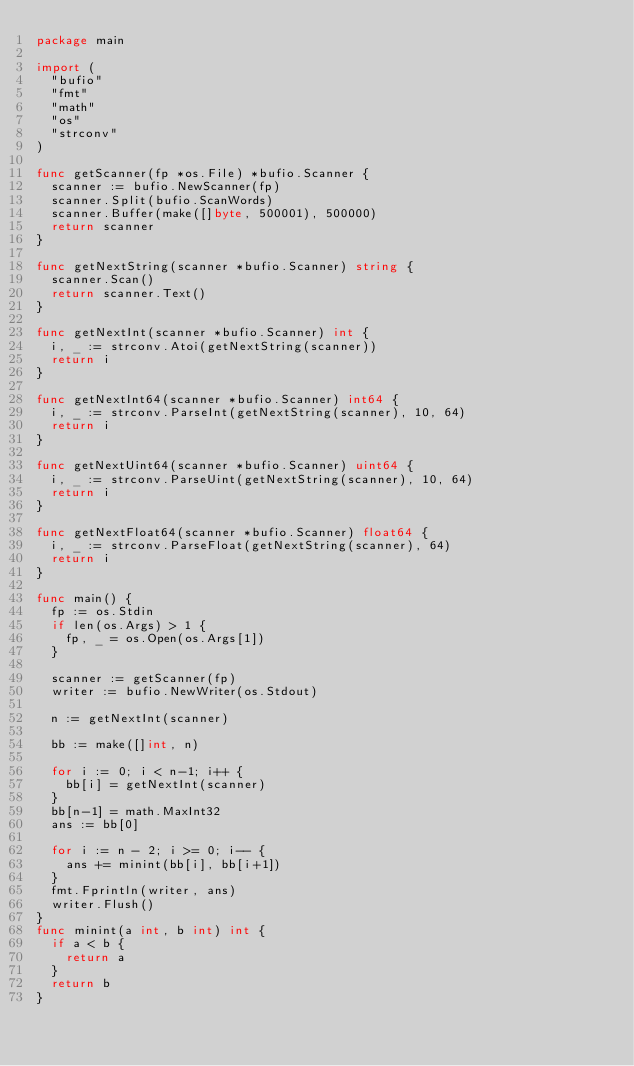Convert code to text. <code><loc_0><loc_0><loc_500><loc_500><_Go_>package main

import (
	"bufio"
	"fmt"
	"math"
	"os"
	"strconv"
)

func getScanner(fp *os.File) *bufio.Scanner {
	scanner := bufio.NewScanner(fp)
	scanner.Split(bufio.ScanWords)
	scanner.Buffer(make([]byte, 500001), 500000)
	return scanner
}

func getNextString(scanner *bufio.Scanner) string {
	scanner.Scan()
	return scanner.Text()
}

func getNextInt(scanner *bufio.Scanner) int {
	i, _ := strconv.Atoi(getNextString(scanner))
	return i
}

func getNextInt64(scanner *bufio.Scanner) int64 {
	i, _ := strconv.ParseInt(getNextString(scanner), 10, 64)
	return i
}

func getNextUint64(scanner *bufio.Scanner) uint64 {
	i, _ := strconv.ParseUint(getNextString(scanner), 10, 64)
	return i
}

func getNextFloat64(scanner *bufio.Scanner) float64 {
	i, _ := strconv.ParseFloat(getNextString(scanner), 64)
	return i
}

func main() {
	fp := os.Stdin
	if len(os.Args) > 1 {
		fp, _ = os.Open(os.Args[1])
	}

	scanner := getScanner(fp)
	writer := bufio.NewWriter(os.Stdout)

	n := getNextInt(scanner)

	bb := make([]int, n)

	for i := 0; i < n-1; i++ {
		bb[i] = getNextInt(scanner)
	}
	bb[n-1] = math.MaxInt32
	ans := bb[0]

	for i := n - 2; i >= 0; i-- {
		ans += minint(bb[i], bb[i+1])
	}
	fmt.Fprintln(writer, ans)
	writer.Flush()
}
func minint(a int, b int) int {
	if a < b {
		return a
	}
	return b
}
</code> 